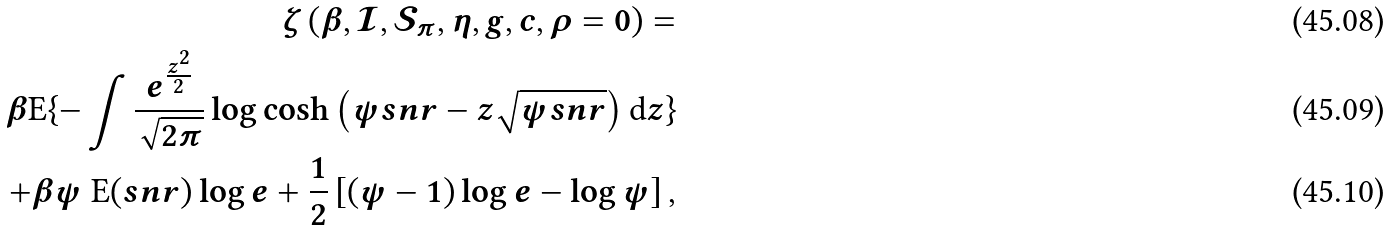<formula> <loc_0><loc_0><loc_500><loc_500>\zeta \left ( \beta , \mathcal { I } , \mathcal { S } _ { \pi } , \eta , g , c , \rho = 0 \right ) = \\ \beta \text {E} \{ - \int \frac { e ^ { \frac { z ^ { 2 } } { 2 } } } { \sqrt { 2 \pi } } \log \cosh \left ( \psi s n r - z \sqrt { \psi s n r } \right ) \text {d} z \} \\ + \beta \psi \text { E} ( s n r ) \log e + \frac { 1 } { 2 } \left [ ( \psi - 1 ) \log e - \log \psi \right ] ,</formula> 